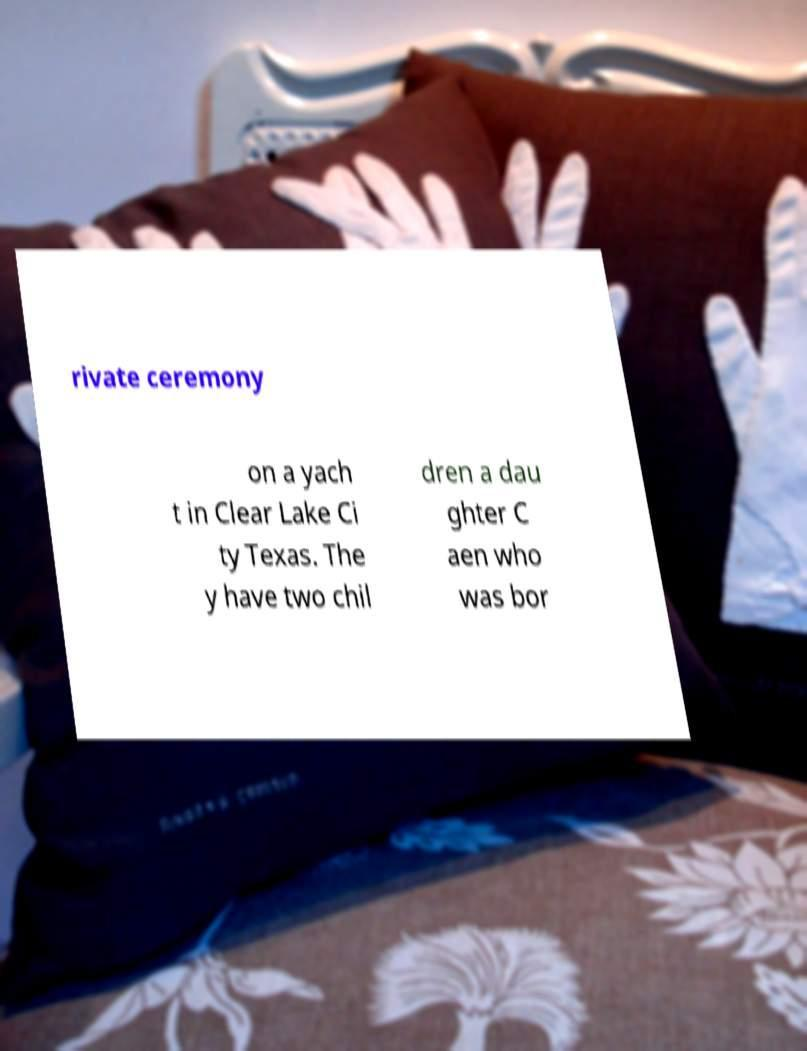Can you accurately transcribe the text from the provided image for me? rivate ceremony on a yach t in Clear Lake Ci ty Texas. The y have two chil dren a dau ghter C aen who was bor 